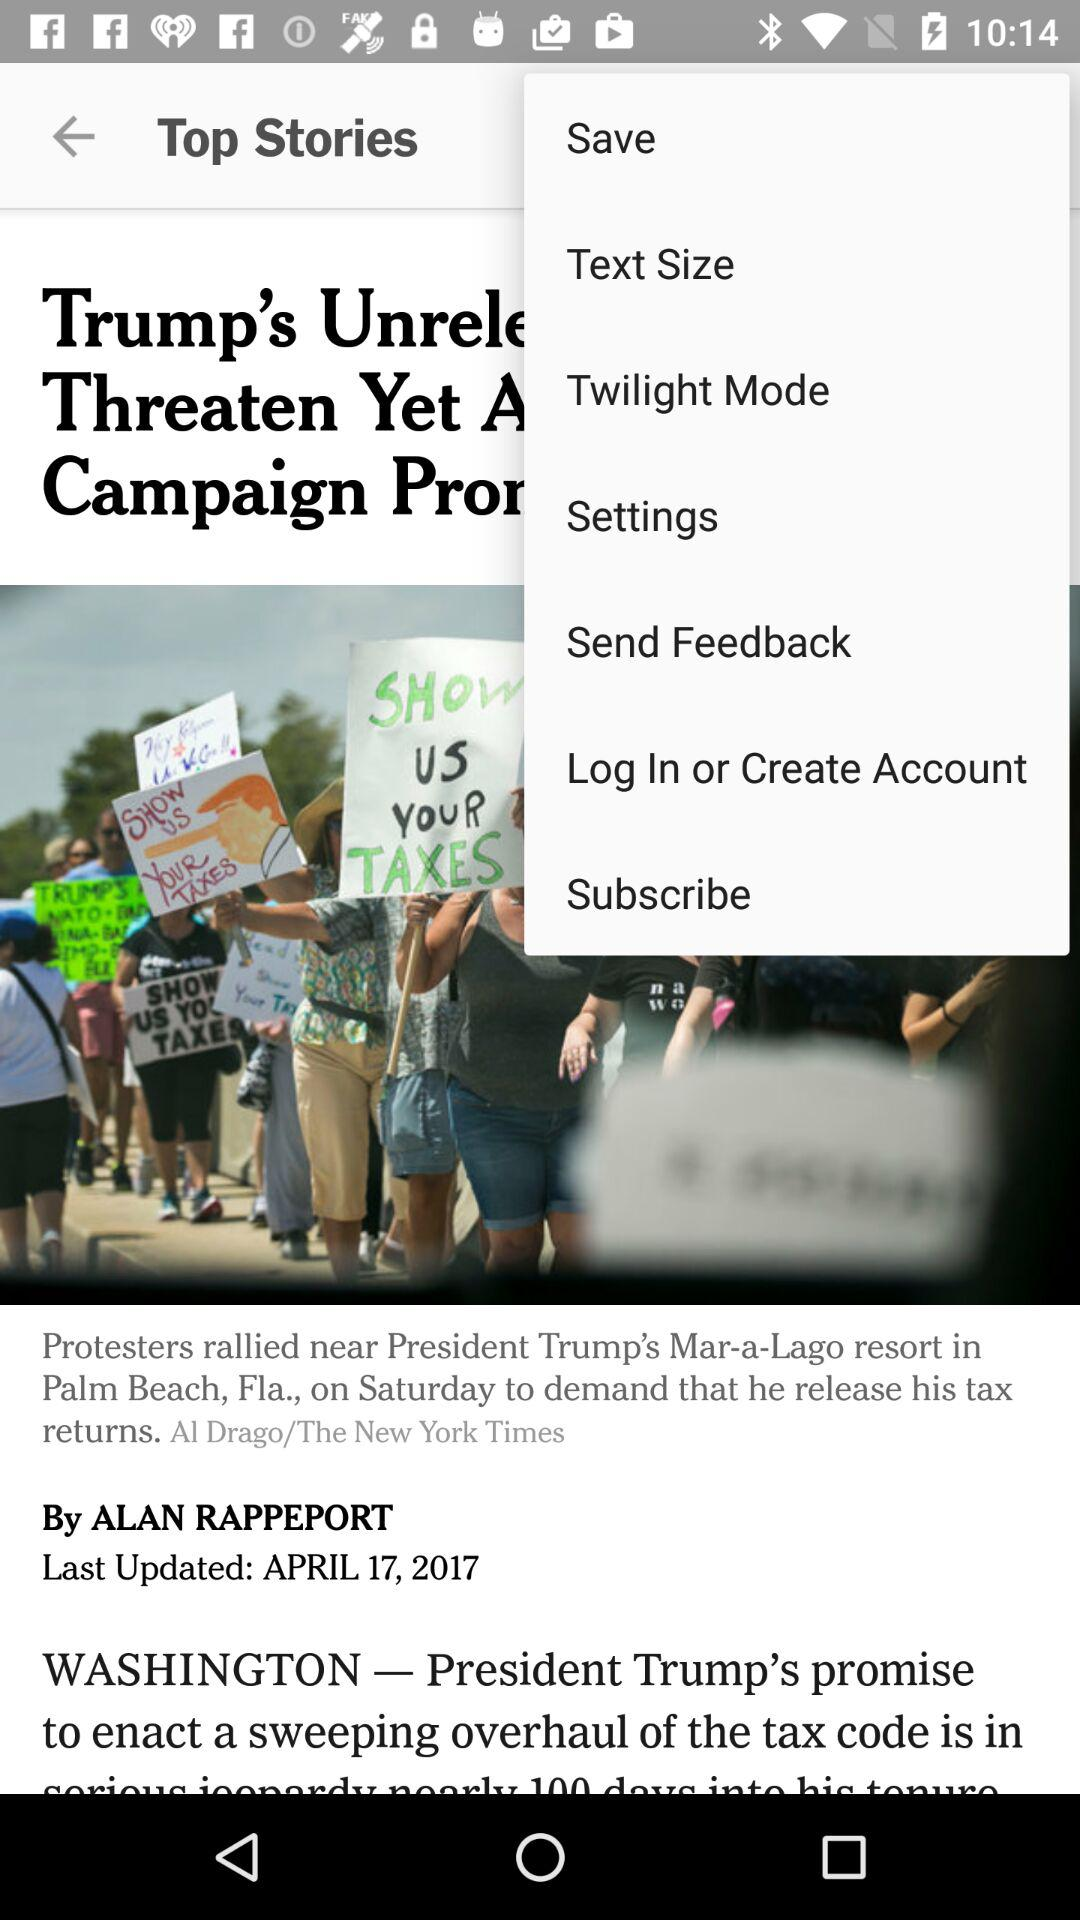What date was the article last updated? The article was last updated on April 17, 2017. 